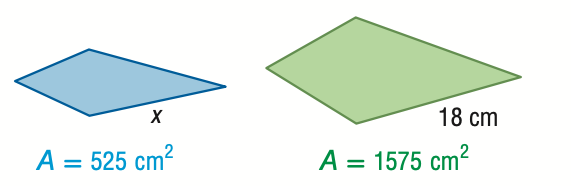Question: For the pair of similar figures, use the given areas to find x.
Choices:
A. 6.0
B. 10.4
C. 31.2
D. 54.0
Answer with the letter. Answer: B Question: For the pair of similar figures, use the given areas to find the scale factor from the blue to the green figure.
Choices:
A. \frac { 1 } { 3 }
B. \frac { 1 } { \sqrt { 3 } }
C. \frac { \sqrt { 3 } } { 1 }
D. \frac { 3 } { 1 }
Answer with the letter. Answer: B 